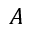Convert formula to latex. <formula><loc_0><loc_0><loc_500><loc_500>A</formula> 